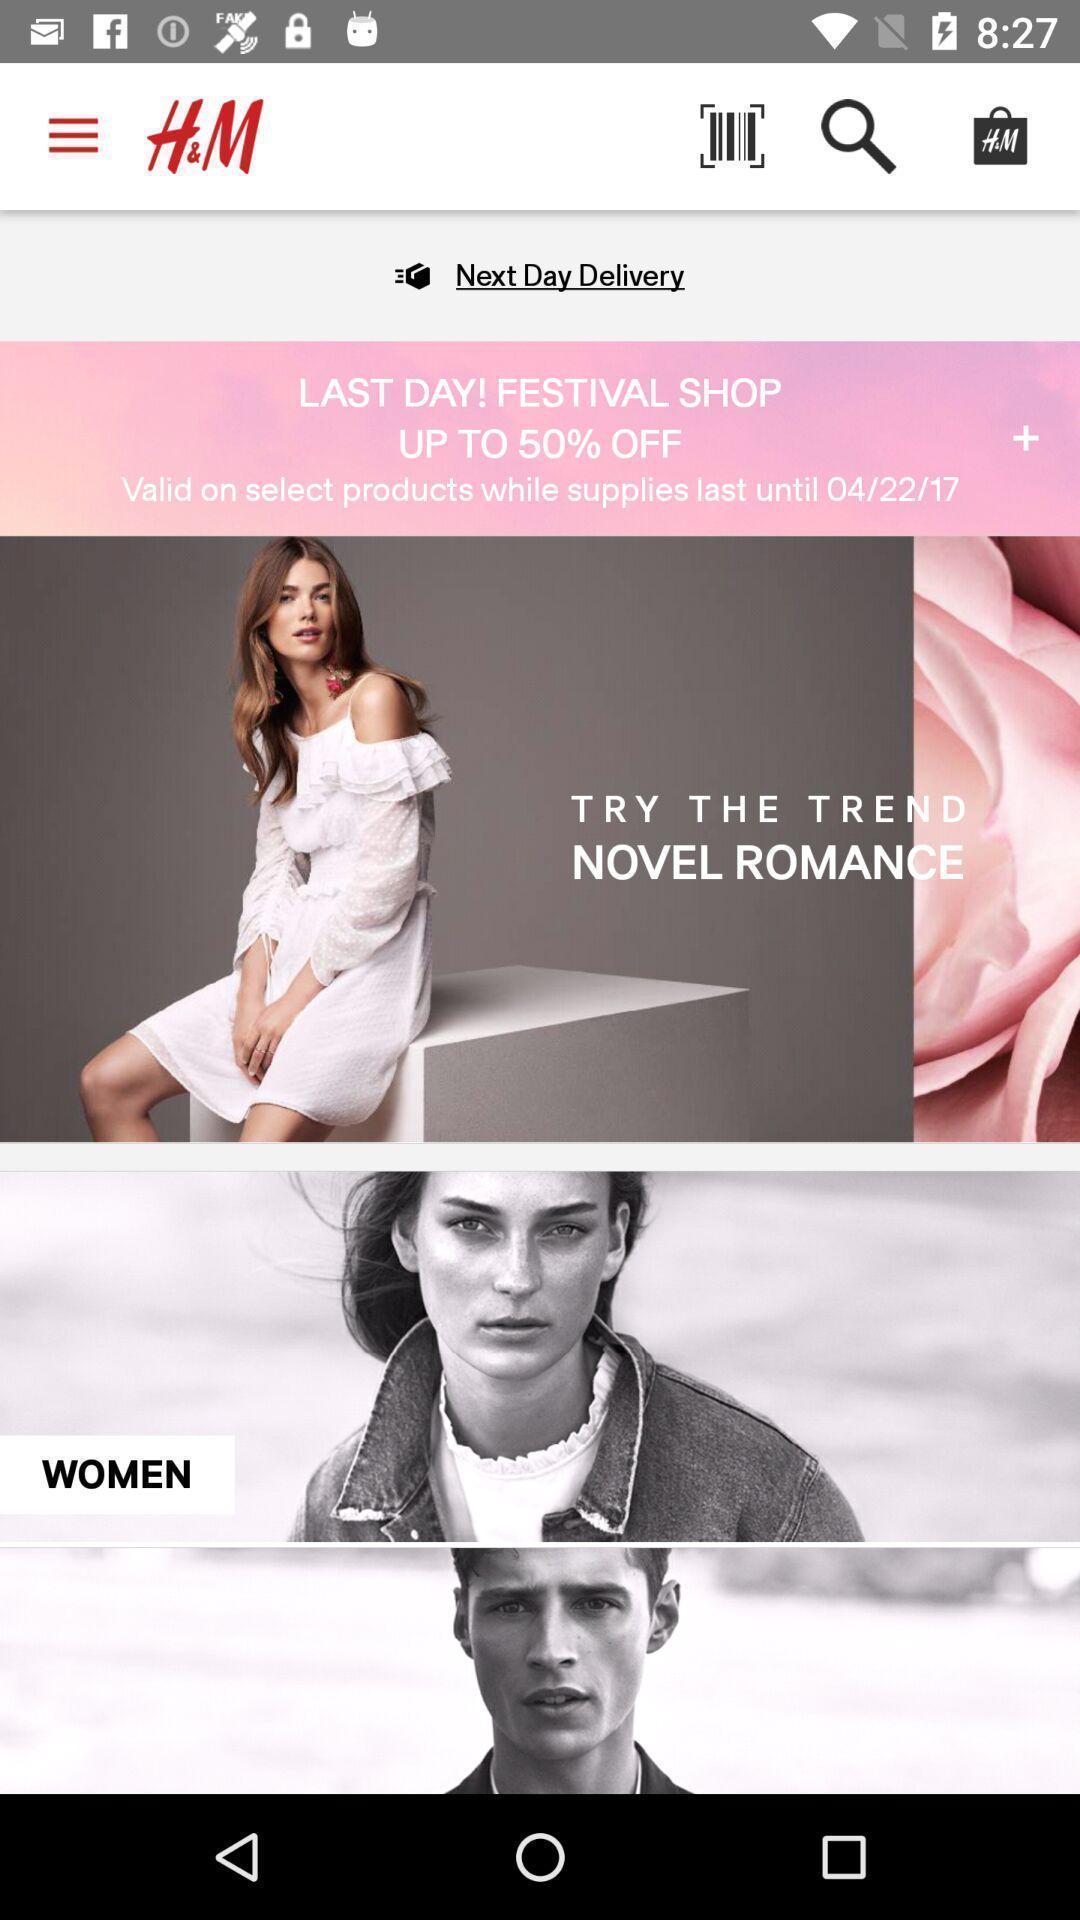Explain the elements present in this screenshot. Screen displaying the page of a shopping app. 